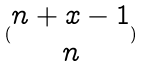Convert formula to latex. <formula><loc_0><loc_0><loc_500><loc_500>( \begin{matrix} n + x - 1 \\ n \end{matrix} )</formula> 